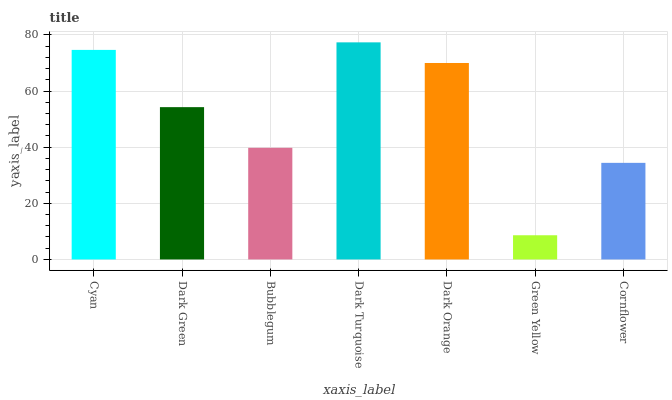Is Green Yellow the minimum?
Answer yes or no. Yes. Is Dark Turquoise the maximum?
Answer yes or no. Yes. Is Dark Green the minimum?
Answer yes or no. No. Is Dark Green the maximum?
Answer yes or no. No. Is Cyan greater than Dark Green?
Answer yes or no. Yes. Is Dark Green less than Cyan?
Answer yes or no. Yes. Is Dark Green greater than Cyan?
Answer yes or no. No. Is Cyan less than Dark Green?
Answer yes or no. No. Is Dark Green the high median?
Answer yes or no. Yes. Is Dark Green the low median?
Answer yes or no. Yes. Is Bubblegum the high median?
Answer yes or no. No. Is Cornflower the low median?
Answer yes or no. No. 